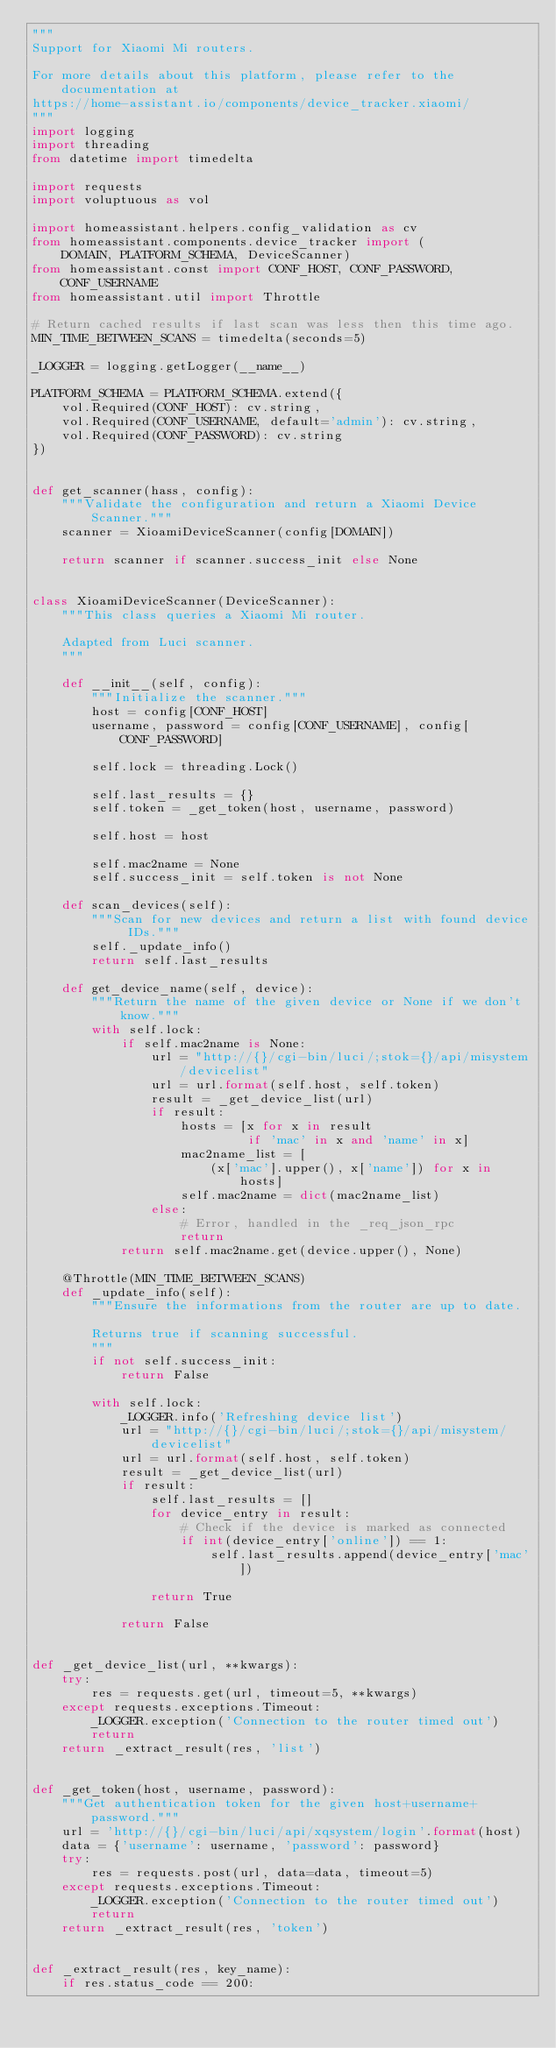Convert code to text. <code><loc_0><loc_0><loc_500><loc_500><_Python_>"""
Support for Xiaomi Mi routers.

For more details about this platform, please refer to the documentation at
https://home-assistant.io/components/device_tracker.xiaomi/
"""
import logging
import threading
from datetime import timedelta

import requests
import voluptuous as vol

import homeassistant.helpers.config_validation as cv
from homeassistant.components.device_tracker import (
    DOMAIN, PLATFORM_SCHEMA, DeviceScanner)
from homeassistant.const import CONF_HOST, CONF_PASSWORD, CONF_USERNAME
from homeassistant.util import Throttle

# Return cached results if last scan was less then this time ago.
MIN_TIME_BETWEEN_SCANS = timedelta(seconds=5)

_LOGGER = logging.getLogger(__name__)

PLATFORM_SCHEMA = PLATFORM_SCHEMA.extend({
    vol.Required(CONF_HOST): cv.string,
    vol.Required(CONF_USERNAME, default='admin'): cv.string,
    vol.Required(CONF_PASSWORD): cv.string
})


def get_scanner(hass, config):
    """Validate the configuration and return a Xiaomi Device Scanner."""
    scanner = XioamiDeviceScanner(config[DOMAIN])

    return scanner if scanner.success_init else None


class XioamiDeviceScanner(DeviceScanner):
    """This class queries a Xiaomi Mi router.

    Adapted from Luci scanner.
    """

    def __init__(self, config):
        """Initialize the scanner."""
        host = config[CONF_HOST]
        username, password = config[CONF_USERNAME], config[CONF_PASSWORD]

        self.lock = threading.Lock()

        self.last_results = {}
        self.token = _get_token(host, username, password)

        self.host = host

        self.mac2name = None
        self.success_init = self.token is not None

    def scan_devices(self):
        """Scan for new devices and return a list with found device IDs."""
        self._update_info()
        return self.last_results

    def get_device_name(self, device):
        """Return the name of the given device or None if we don't know."""
        with self.lock:
            if self.mac2name is None:
                url = "http://{}/cgi-bin/luci/;stok={}/api/misystem/devicelist"
                url = url.format(self.host, self.token)
                result = _get_device_list(url)
                if result:
                    hosts = [x for x in result
                             if 'mac' in x and 'name' in x]
                    mac2name_list = [
                        (x['mac'].upper(), x['name']) for x in hosts]
                    self.mac2name = dict(mac2name_list)
                else:
                    # Error, handled in the _req_json_rpc
                    return
            return self.mac2name.get(device.upper(), None)

    @Throttle(MIN_TIME_BETWEEN_SCANS)
    def _update_info(self):
        """Ensure the informations from the router are up to date.

        Returns true if scanning successful.
        """
        if not self.success_init:
            return False

        with self.lock:
            _LOGGER.info('Refreshing device list')
            url = "http://{}/cgi-bin/luci/;stok={}/api/misystem/devicelist"
            url = url.format(self.host, self.token)
            result = _get_device_list(url)
            if result:
                self.last_results = []
                for device_entry in result:
                    # Check if the device is marked as connected
                    if int(device_entry['online']) == 1:
                        self.last_results.append(device_entry['mac'])

                return True

            return False


def _get_device_list(url, **kwargs):
    try:
        res = requests.get(url, timeout=5, **kwargs)
    except requests.exceptions.Timeout:
        _LOGGER.exception('Connection to the router timed out')
        return
    return _extract_result(res, 'list')


def _get_token(host, username, password):
    """Get authentication token for the given host+username+password."""
    url = 'http://{}/cgi-bin/luci/api/xqsystem/login'.format(host)
    data = {'username': username, 'password': password}
    try:
        res = requests.post(url, data=data, timeout=5)
    except requests.exceptions.Timeout:
        _LOGGER.exception('Connection to the router timed out')
        return
    return _extract_result(res, 'token')


def _extract_result(res, key_name):
    if res.status_code == 200:</code> 